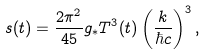<formula> <loc_0><loc_0><loc_500><loc_500>s ( t ) = \frac { 2 \pi ^ { 2 } } { 4 5 } g _ { * } T ^ { 3 } ( t ) \left ( \frac { k } { \hbar { c } } \right ) ^ { 3 } ,</formula> 